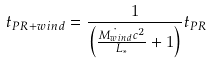Convert formula to latex. <formula><loc_0><loc_0><loc_500><loc_500>t _ { P R + w i n d } = \frac { 1 } { \left ( \frac { \dot { M _ { w i n d } } c ^ { 2 } } { L _ { * } } + 1 \right ) } t _ { P R }</formula> 